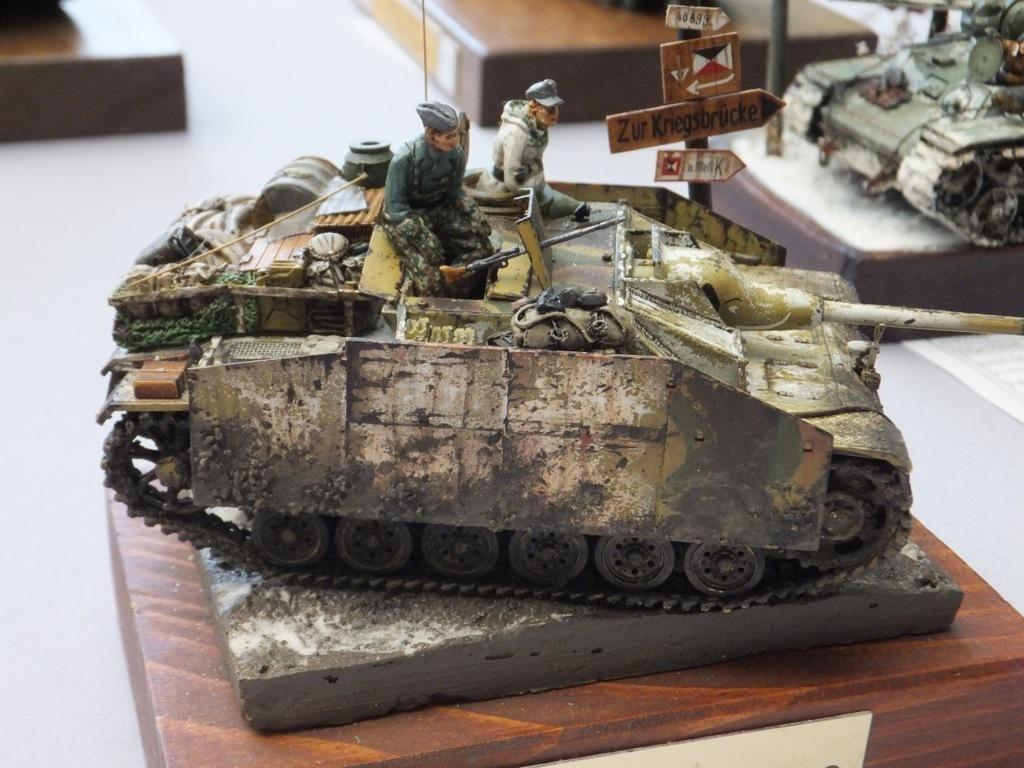What type of toys are present in the image? There are war tanker toys in the image. Where are the toys located? The war tanker toys are on a table. How many snakes can be seen slithering around the war tanker toys in the image? There are no snakes or any type of attraction involving snakes present in the image. The image only features war tanker toys on a table. 